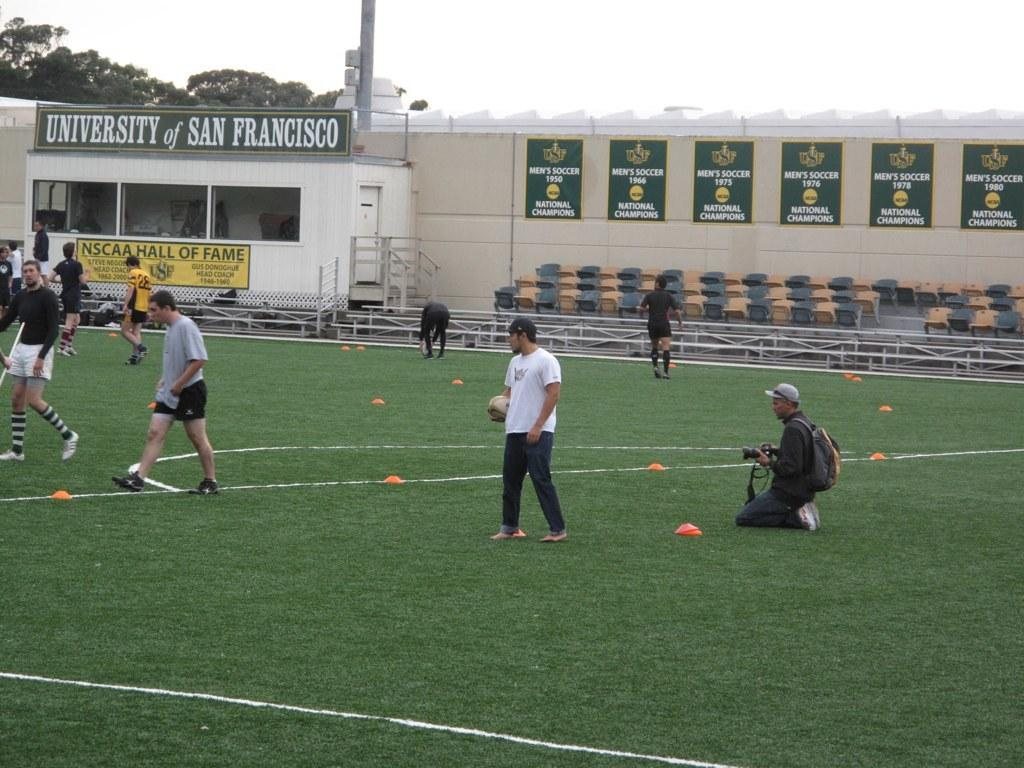<image>
Offer a succinct explanation of the picture presented. Men gather for a rugby game on a field at University of San Francisco. 